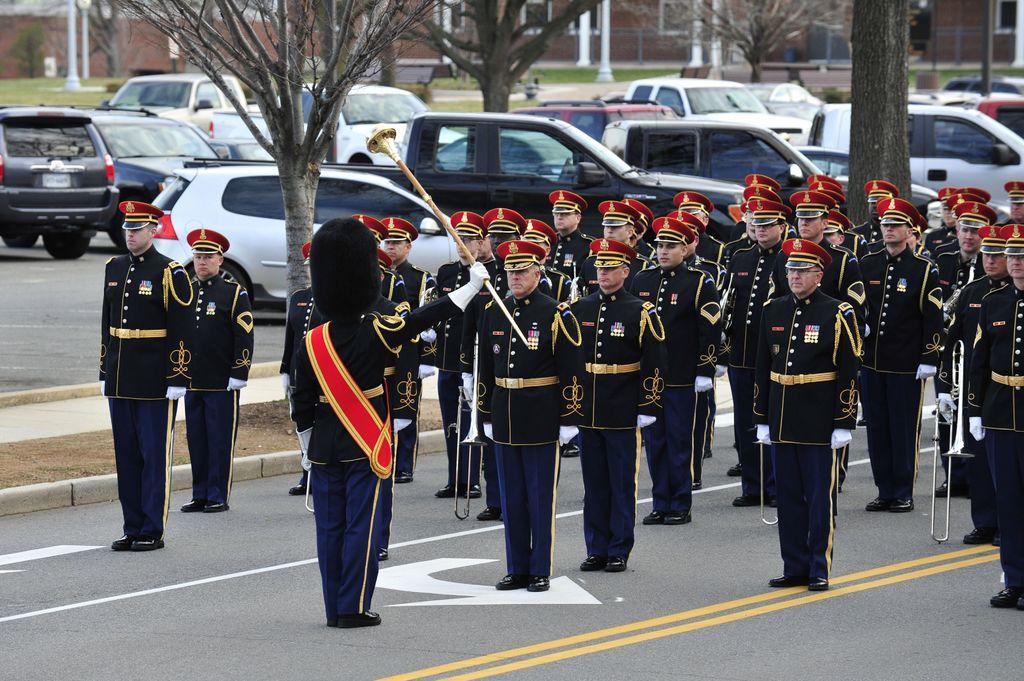How would you summarize this image in a sentence or two? In this image, we can see some people standing and there are some cars parked, there are some trees, in the background there are some buildings. 